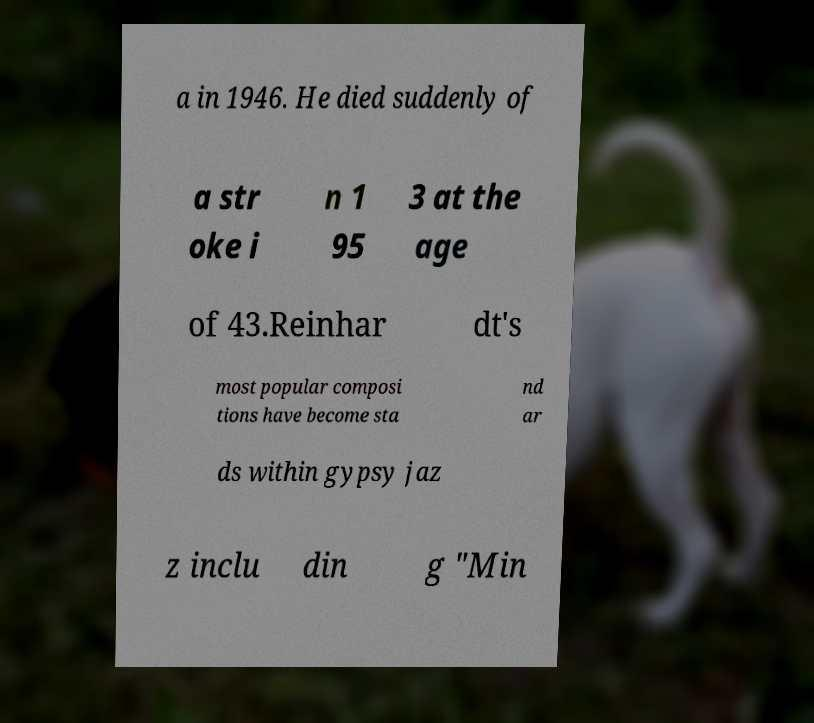Could you assist in decoding the text presented in this image and type it out clearly? a in 1946. He died suddenly of a str oke i n 1 95 3 at the age of 43.Reinhar dt's most popular composi tions have become sta nd ar ds within gypsy jaz z inclu din g "Min 